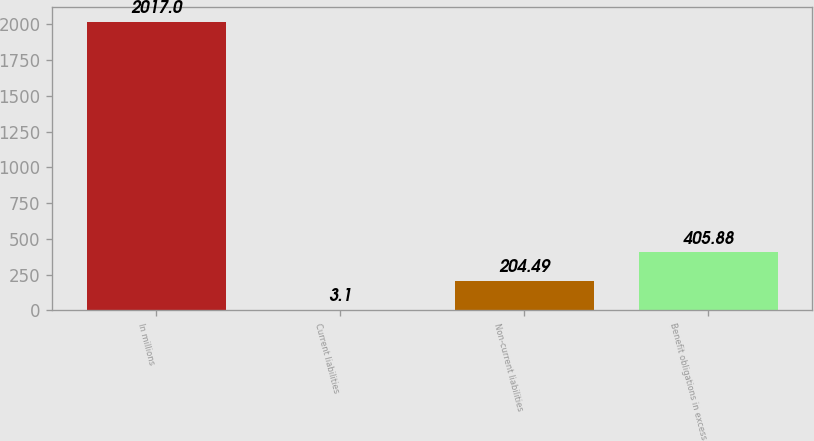Convert chart. <chart><loc_0><loc_0><loc_500><loc_500><bar_chart><fcel>In millions<fcel>Current liabilities<fcel>Non-current liabilities<fcel>Benefit obligations in excess<nl><fcel>2017<fcel>3.1<fcel>204.49<fcel>405.88<nl></chart> 